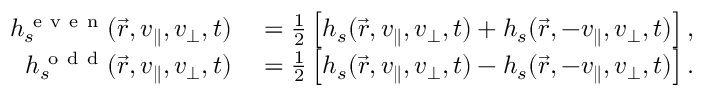<formula> <loc_0><loc_0><loc_500><loc_500>\begin{array} { r l } { h _ { s } ^ { e v e n } ( \vec { r } , v _ { \| } , v _ { \perp } , t ) } & = \frac { 1 } { 2 } \left [ h _ { s } ( \vec { r } , v _ { \| } , v _ { \perp } , t ) + h _ { s } ( \vec { r } , - v _ { \| } , v _ { \perp } , t ) \right ] , } \\ { h _ { s } ^ { o d d } ( \vec { r } , v _ { \| } , v _ { \perp } , t ) } & = \frac { 1 } { 2 } \left [ h _ { s } ( \vec { r } , v _ { \| } , v _ { \perp } , t ) - h _ { s } ( \vec { r } , - v _ { \| } , v _ { \perp } , t ) \right ] . } \end{array}</formula> 